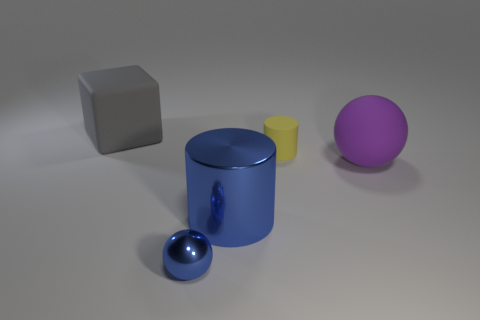Add 4 small blue things. How many objects exist? 9 Subtract all cylinders. How many objects are left? 3 Add 3 yellow cylinders. How many yellow cylinders exist? 4 Subtract 0 green cylinders. How many objects are left? 5 Subtract all gray matte blocks. Subtract all large shiny things. How many objects are left? 3 Add 5 big blue metal objects. How many big blue metal objects are left? 6 